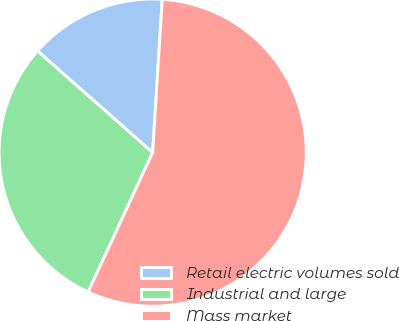Convert chart to OTSL. <chart><loc_0><loc_0><loc_500><loc_500><pie_chart><fcel>Retail electric volumes sold<fcel>Industrial and large<fcel>Mass market<nl><fcel>14.49%<fcel>29.61%<fcel>55.9%<nl></chart> 